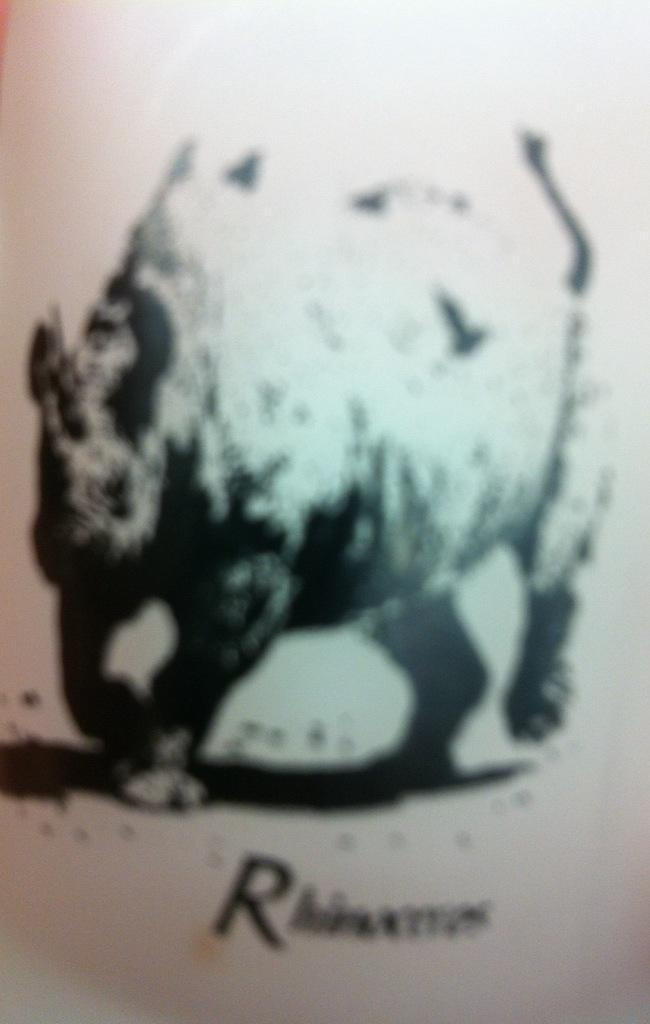What type of visual is the image? The image is a poster. What animal is depicted in the poster? There is a depiction of a hippopotamus in the image. Is there any text present in the image? Yes, there is text at the bottom of the image. Where is the scarecrow sitting in the image? There is no scarecrow present in the image. What type of furniture is visible in the image? The image is a poster, so there is no furniture like a desk in the image. 